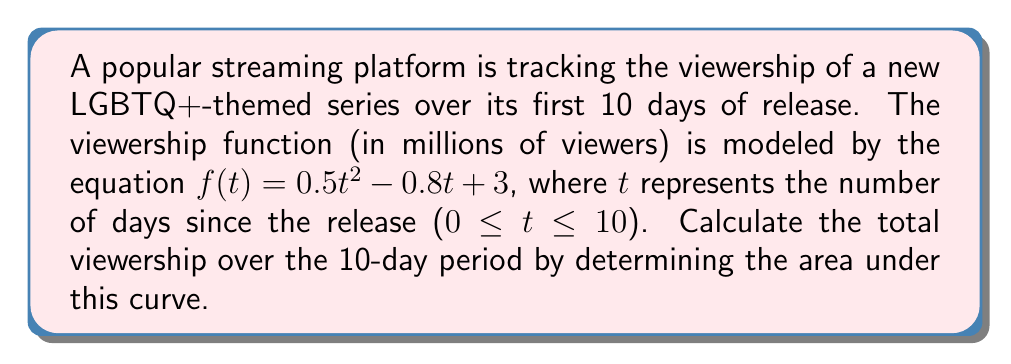Teach me how to tackle this problem. To find the total viewership over the 10-day period, we need to calculate the definite integral of the viewership function from t = 0 to t = 10.

1. The viewership function is $f(t) = 0.5t^2 - 0.8t + 3$

2. We need to evaluate:
   $$\int_0^{10} (0.5t^2 - 0.8t + 3) dt$$

3. Integrate each term:
   $$\left[\frac{0.5t^3}{3} - 0.4t^2 + 3t\right]_0^{10}$$

4. Evaluate the antiderivative at the upper and lower limits:
   $$\left(\frac{0.5(10^3)}{3} - 0.4(10^2) + 3(10)\right) - \left(\frac{0.5(0^3)}{3} - 0.4(0^2) + 3(0)\right)$$

5. Simplify:
   $$\left(\frac{500}{3} - 40 + 30\right) - (0)$$
   $$\frac{500}{3} - 10$$
   $$\frac{500}{3} - \frac{30}{3}$$
   $$\frac{470}{3}$$

6. The result is in millions of viewers, so we can express it as a decimal:
   $$\frac{470}{3} \approx 156.67$$

Therefore, the total viewership over the 10-day period is approximately 156.67 million viewers.
Answer: 156.67 million viewers 